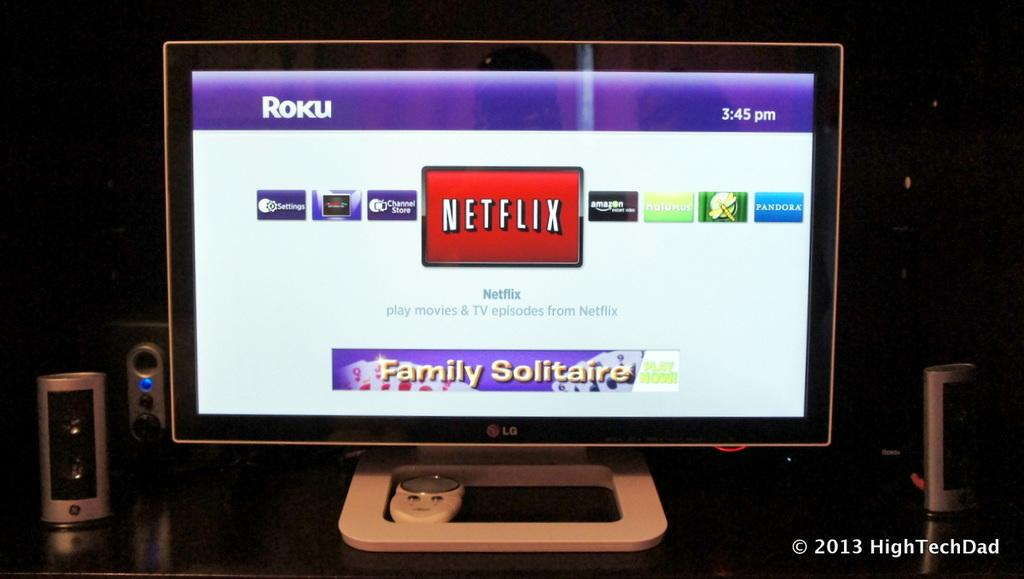<image>
Present a compact description of the photo's key features. Small computer screen with "Netflix" showing on Roku. 